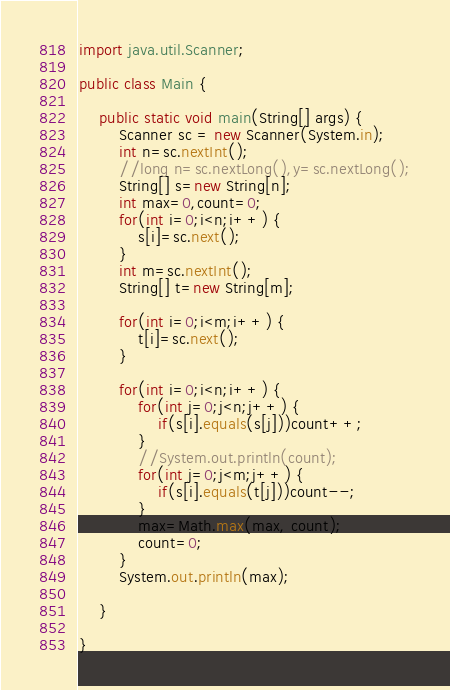<code> <loc_0><loc_0><loc_500><loc_500><_Java_>import java.util.Scanner;

public class Main {

	public static void main(String[] args) {
		Scanner sc = new Scanner(System.in);
		int n=sc.nextInt();
		//long n=sc.nextLong(),y=sc.nextLong();
		String[] s=new String[n];
		int max=0,count=0;
		for(int i=0;i<n;i++) {
			s[i]=sc.next();
		}
		int m=sc.nextInt();
		String[] t=new String[m];

		for(int i=0;i<m;i++) {
			t[i]=sc.next();
		}

		for(int i=0;i<n;i++) {
			for(int j=0;j<n;j++) {
				if(s[i].equals(s[j]))count++;
			}
			//System.out.println(count);
			for(int j=0;j<m;j++) {
				if(s[i].equals(t[j]))count--;
			}
			max=Math.max(max, count);
			count=0;
		}
		System.out.println(max);

	}

}
</code> 